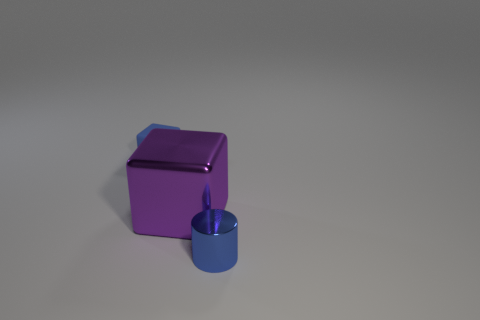What is the color of the other object that is the same shape as the big thing?
Your answer should be compact. Blue. How many things are big blocks or tiny blue matte cubes?
Your answer should be very brief. 2. What number of other objects have the same material as the purple object?
Your response must be concise. 1. Is the number of purple shiny objects less than the number of small green spheres?
Your answer should be very brief. No. Do the small blue object that is to the left of the tiny blue metal object and the big purple block have the same material?
Give a very brief answer. No. What number of cylinders are small cyan shiny objects or blue rubber objects?
Your answer should be compact. 0. What shape is the object that is right of the rubber thing and behind the tiny cylinder?
Keep it short and to the point. Cube. What is the color of the cube that is in front of the blue object that is behind the metallic thing that is in front of the shiny block?
Provide a succinct answer. Purple. Are there fewer metal blocks that are to the right of the cylinder than small yellow matte spheres?
Provide a short and direct response. No. There is a shiny object that is behind the tiny shiny cylinder; is it the same shape as the tiny blue thing that is behind the tiny blue shiny thing?
Provide a succinct answer. Yes. 